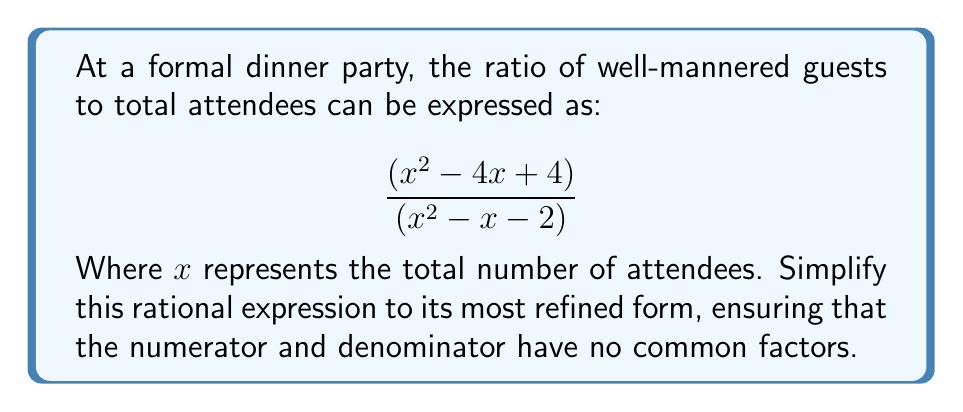Provide a solution to this math problem. Let us approach this simplification with the utmost decorum:

1) First, we shall factor both the numerator and denominator:

   Numerator: $x^2 - 4x + 4 = (x - 2)(x - 2)$
   Denominator: $x^2 - x - 2 = (x + 1)(x - 2)$

2) Our expression now appears as:

   $$\frac{(x - 2)(x - 2)}{(x + 1)(x - 2)}$$

3) We observe that $(x - 2)$ is a common factor in both the numerator and denominator. As proper etiquette dictates, we shall remove this common factor:

   $$\frac{(x - 2)}{(x + 1)}$$

4) This fraction cannot be simplified further, as $(x - 2)$ and $(x + 1)$ share no common factors.

5) However, we must note that this simplified expression is only valid when $x \neq 2$ and $x \neq -1$, as these values would render the denominator zero, which is most unbecoming in polite society.
Answer: $$\frac{x - 2}{x + 1}, \text{ where } x \neq 2 \text{ and } x \neq -1$$ 